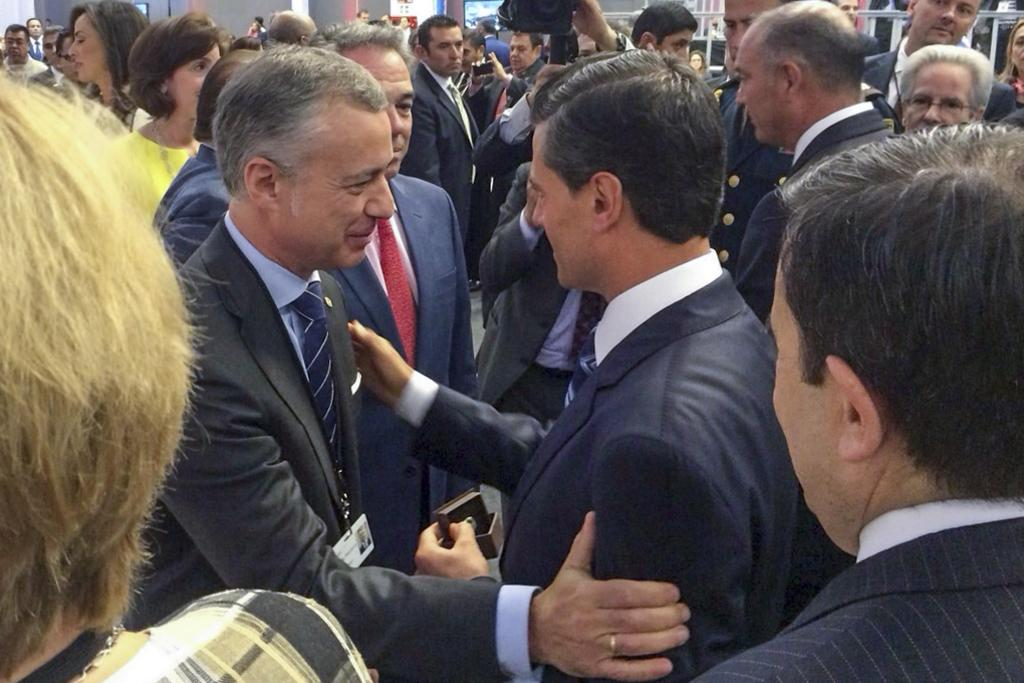What is the main subject of the image? The main subject of the image is a group of people. What is the man at the top of the image doing? The man is holding a camera in the image. What can be seen in the background of the image? There are buildings and metal rods in the background of the image. What type of necklace is the man wearing in the image? There is no mention of a necklace or any jewelry in the image. 